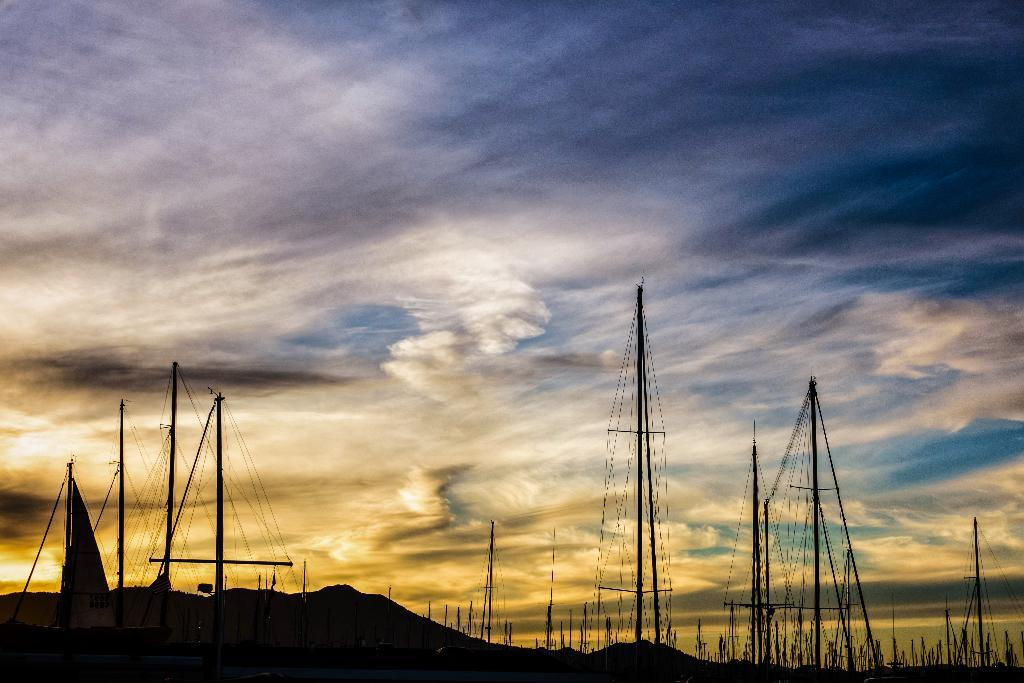What can be seen in the background of the image? The sky is visible in the image. What is the condition of the sky in the image? Clouds are present in the sky. What type of landscape is featured in the image? There are hills in the image. What type of vehicles can be seen in the image? Ships are visible in the image. Can you tell me how many wounds are visible on the clouds in the image? There are no wounds present in the image, as it features clouds in the sky and not any living beings or objects that could have wounds. 